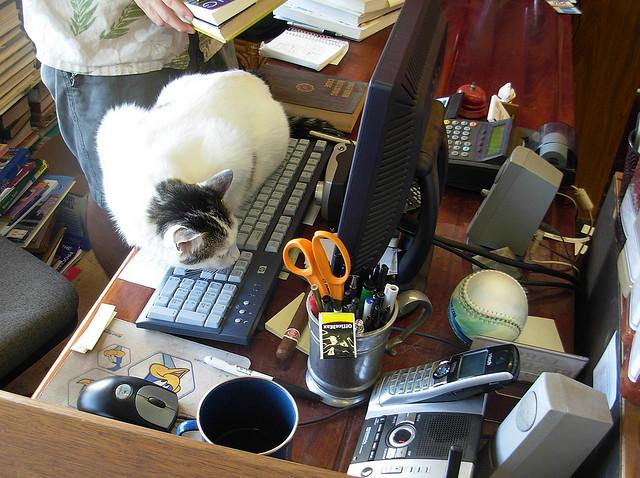What type tobacco product will the person who sits here smoke? Please explain your reasoning. cigar. There is a cigar. 